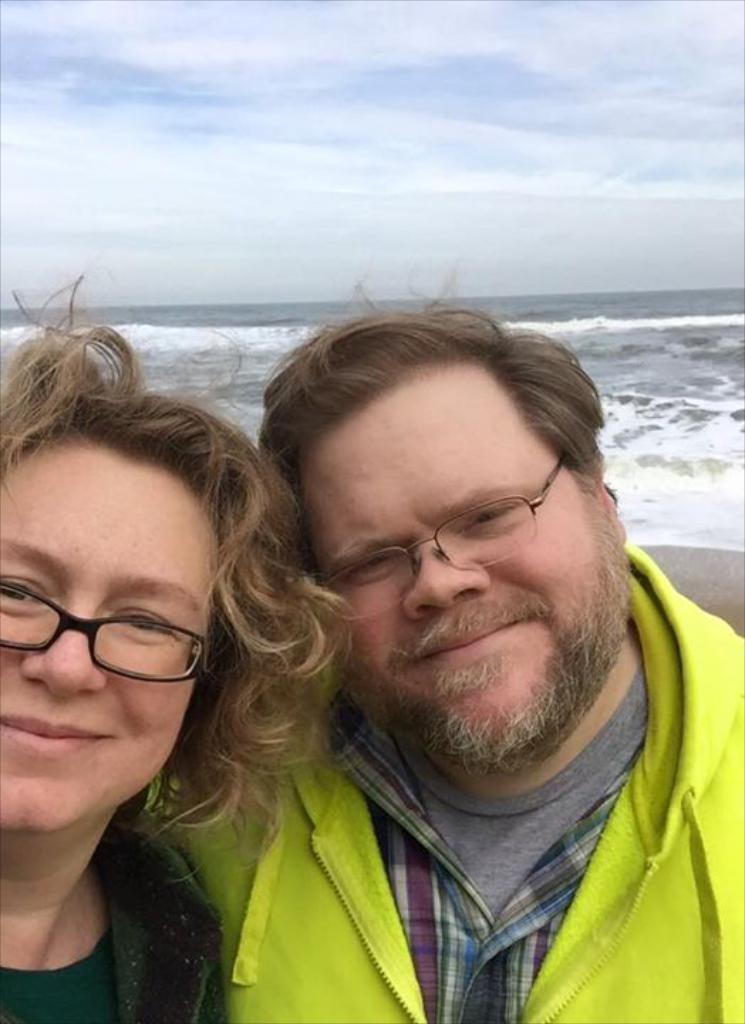Who is present in the image? There is a woman and a man with spectacles in the image. What are the man and woman standing in front of? They are standing in front of a beach. What can be seen above the beach in the image? The sky is visible above the beach. What is the condition of the sky in the image? There are clouds in the sky. What type of quill is the man using to write on the sand in the image? There is no quill or writing on the sand present in the image. How many pumpkins are visible on the beach in the image? There are no pumpkins visible on the beach in the image. 